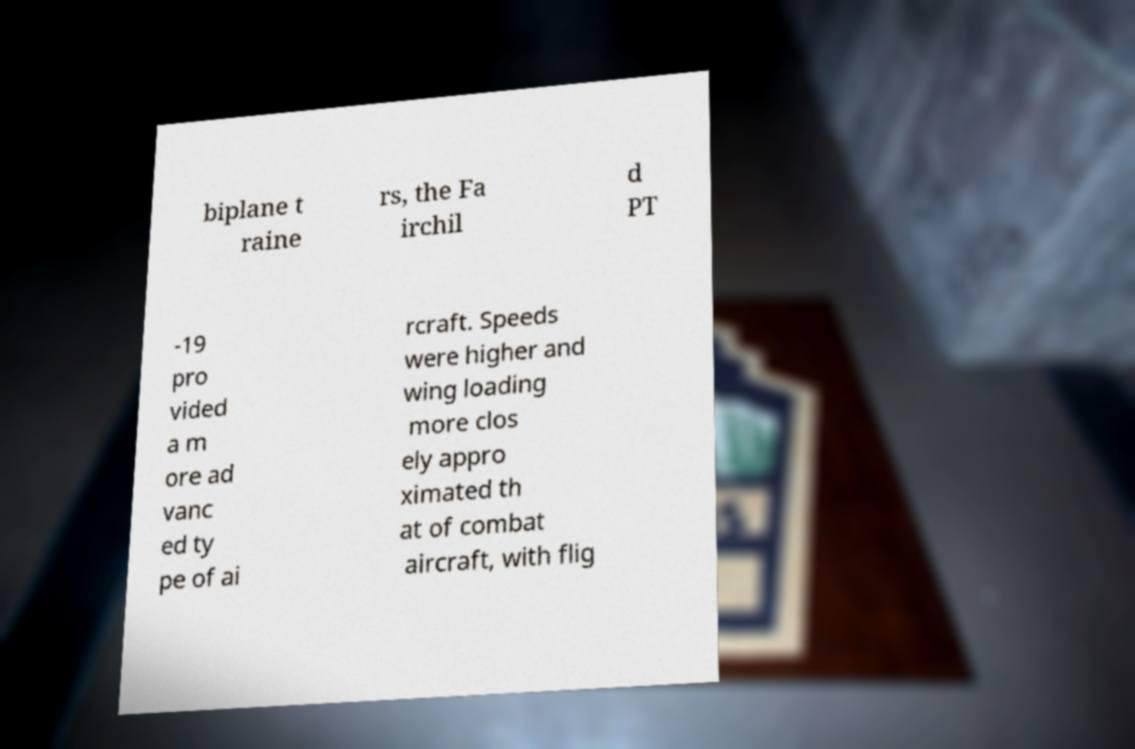What messages or text are displayed in this image? I need them in a readable, typed format. biplane t raine rs, the Fa irchil d PT -19 pro vided a m ore ad vanc ed ty pe of ai rcraft. Speeds were higher and wing loading more clos ely appro ximated th at of combat aircraft, with flig 